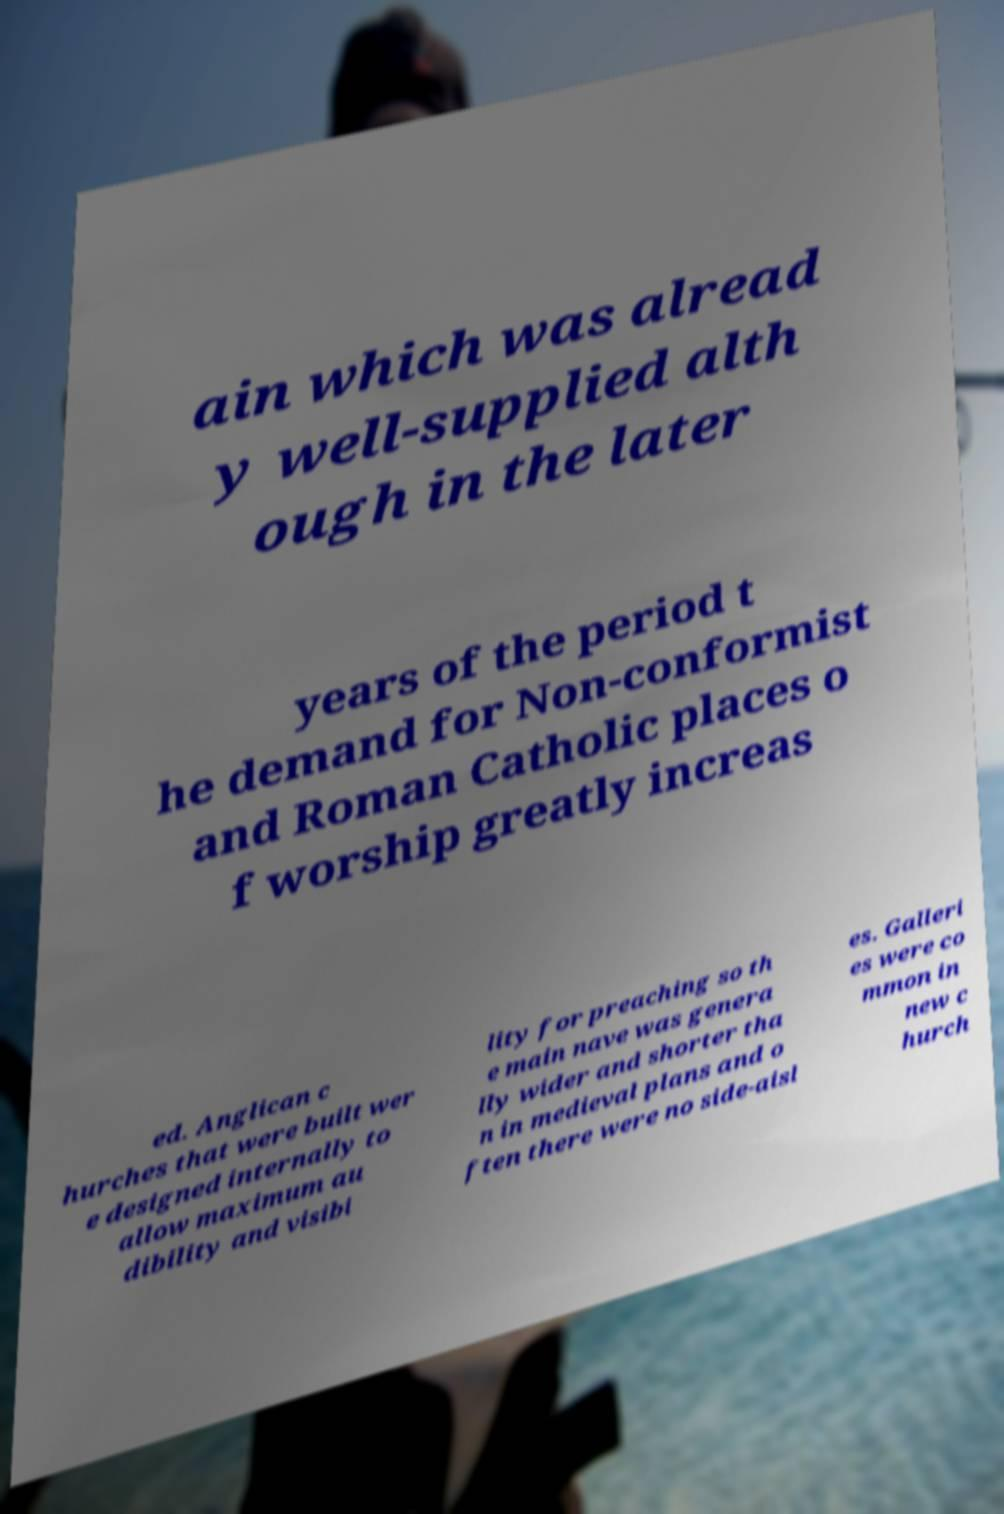Could you extract and type out the text from this image? ain which was alread y well-supplied alth ough in the later years of the period t he demand for Non-conformist and Roman Catholic places o f worship greatly increas ed. Anglican c hurches that were built wer e designed internally to allow maximum au dibility and visibi lity for preaching so th e main nave was genera lly wider and shorter tha n in medieval plans and o ften there were no side-aisl es. Galleri es were co mmon in new c hurch 